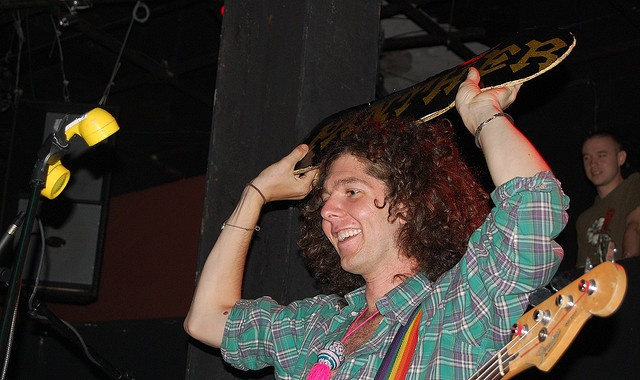Describe the objects in this image and their specific colors. I can see people in black, gray, tan, and darkgray tones, skateboard in black, maroon, and gray tones, and people in black, maroon, brown, and gray tones in this image. 